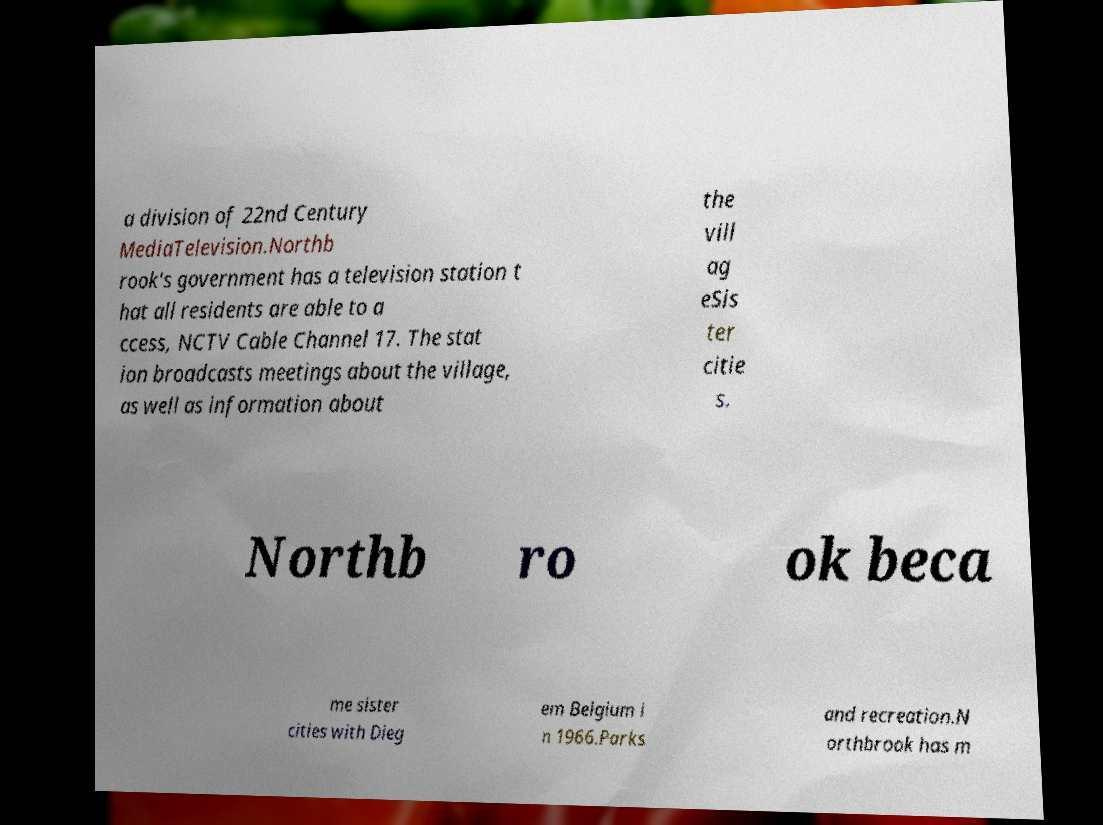Can you read and provide the text displayed in the image?This photo seems to have some interesting text. Can you extract and type it out for me? a division of 22nd Century MediaTelevision.Northb rook's government has a television station t hat all residents are able to a ccess, NCTV Cable Channel 17. The stat ion broadcasts meetings about the village, as well as information about the vill ag eSis ter citie s. Northb ro ok beca me sister cities with Dieg em Belgium i n 1966.Parks and recreation.N orthbrook has m 